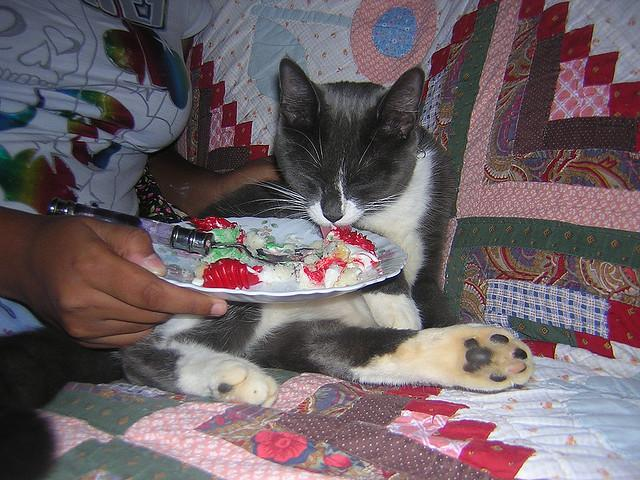How many toes does cats are supposed to have?

Choices:
A) 18
B) 24
C) 11
D) 14 18 